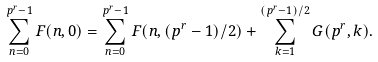Convert formula to latex. <formula><loc_0><loc_0><loc_500><loc_500>\sum _ { n = 0 } ^ { p ^ { r } - 1 } F ( n , 0 ) = \sum _ { n = 0 } ^ { p ^ { r } - 1 } F ( n , ( p ^ { r } - 1 ) / 2 ) + \sum _ { k = 1 } ^ { ( p ^ { r } - 1 ) / 2 } G ( p ^ { r } , k ) .</formula> 